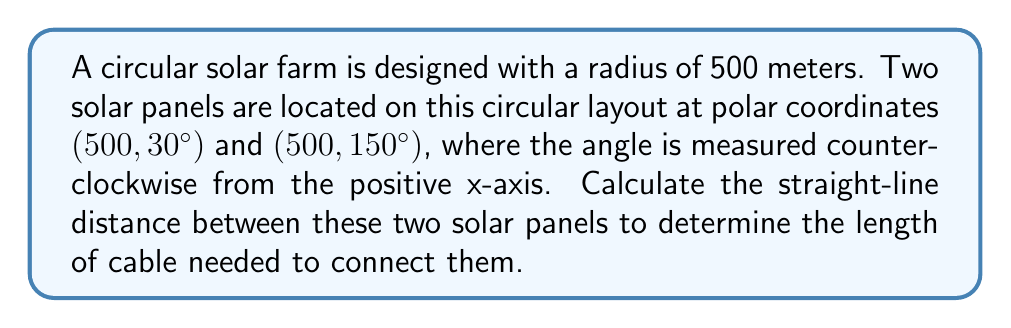Solve this math problem. To solve this problem, we'll use the formula for the distance between two points in polar coordinates:

$$d = \sqrt{r_1^2 + r_2^2 - 2r_1r_2 \cos(\theta_2 - \theta_1)}$$

Where:
- $d$ is the distance between the two points
- $r_1$ and $r_2$ are the radial distances of the two points
- $\theta_1$ and $\theta_2$ are the angular coordinates of the two points

Given:
- Point 1: $(r_1, \theta_1) = (500, 30°)$
- Point 2: $(r_2, \theta_2) = (500, 150°)$

Step 1: Identify the values
$r_1 = r_2 = 500$ meters
$\theta_2 - \theta_1 = 150° - 30° = 120°$

Step 2: Convert the angle to radians
$120° = \frac{120 \pi}{180} = \frac{2\pi}{3}$ radians

Step 3: Substitute the values into the formula
$$d = \sqrt{500^2 + 500^2 - 2(500)(500) \cos(\frac{2\pi}{3})}$$

Step 4: Simplify
$$d = \sqrt{250000 + 250000 - 500000 \cos(\frac{2\pi}{3})}$$
$$d = \sqrt{500000 - 500000 \cos(\frac{2\pi}{3})}$$
$$d = \sqrt{500000 (1 - \cos(\frac{2\pi}{3}))}$$

Step 5: Evaluate $\cos(\frac{2\pi}{3})$
$\cos(\frac{2\pi}{3}) = -\frac{1}{2}$

Step 6: Substitute and calculate
$$d = \sqrt{500000 (1 - (-\frac{1}{2}))}$$
$$d = \sqrt{500000 (\frac{3}{2})}$$
$$d = \sqrt{750000}$$
$$d = 500\sqrt{3} \approx 866.03$$
Answer: The straight-line distance between the two solar panels is $500\sqrt{3}$ meters, or approximately 866.03 meters. 